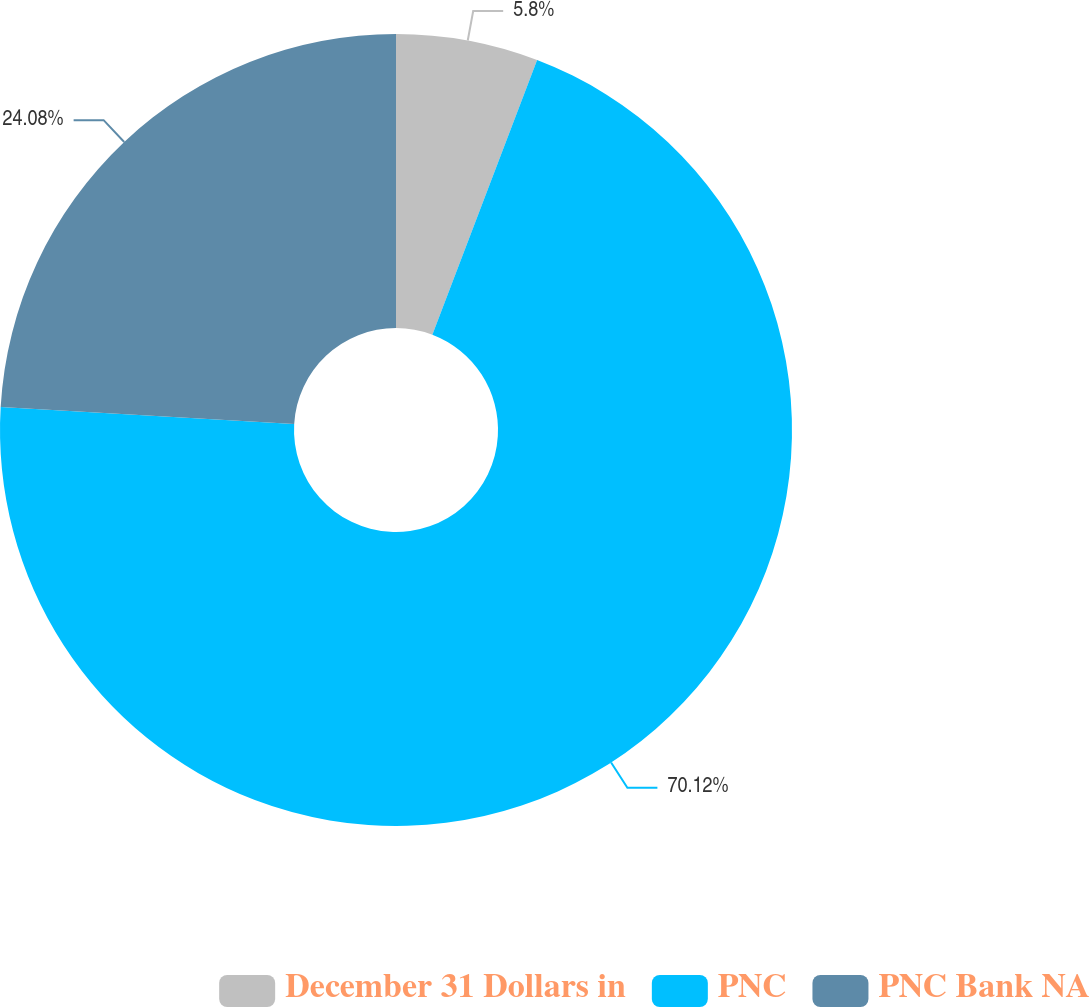Convert chart. <chart><loc_0><loc_0><loc_500><loc_500><pie_chart><fcel>December 31 Dollars in<fcel>PNC<fcel>PNC Bank NA<nl><fcel>5.8%<fcel>70.13%<fcel>24.08%<nl></chart> 